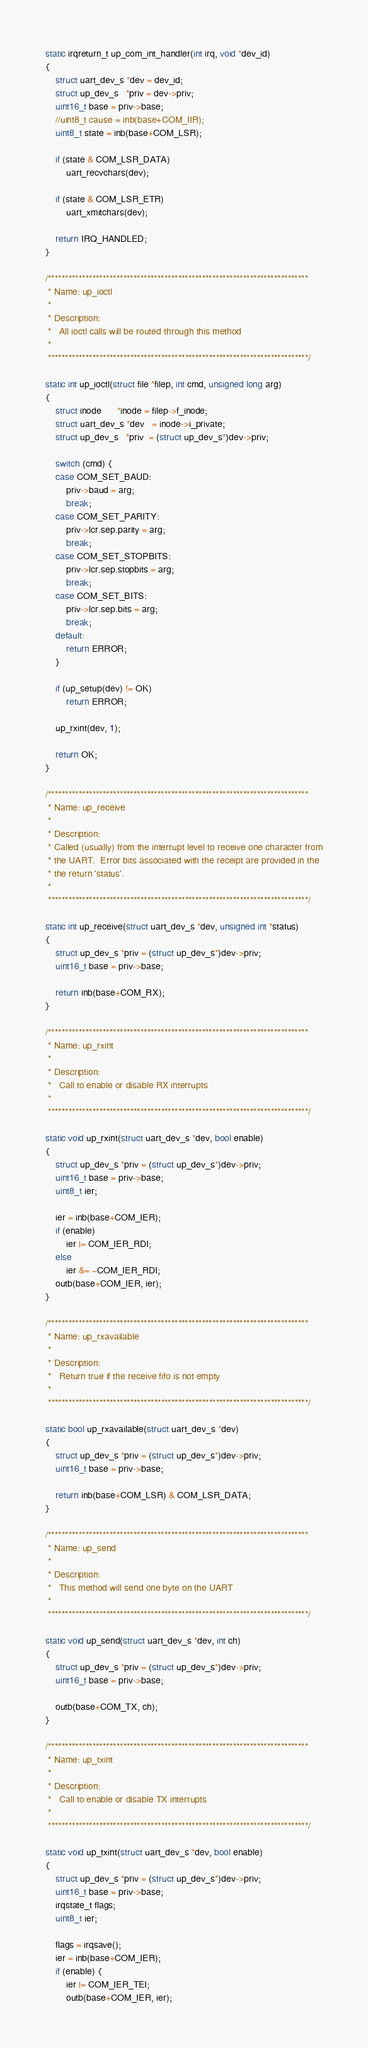<code> <loc_0><loc_0><loc_500><loc_500><_C_>
static irqreturn_t up_com_int_handler(int irq, void *dev_id)
{
    struct uart_dev_s *dev = dev_id;
    struct up_dev_s   *priv = dev->priv;
    uint16_t base = priv->base;
    //uint8_t cause = inb(base+COM_IIR);
    uint8_t state = inb(base+COM_LSR);

    if (state & COM_LSR_DATA)
        uart_recvchars(dev);

    if (state & COM_LSR_ETR)
        uart_xmitchars(dev);

    return IRQ_HANDLED;
}

/****************************************************************************
 * Name: up_ioctl
 *
 * Description:
 *   All ioctl calls will be routed through this method
 *
 ****************************************************************************/

static int up_ioctl(struct file *filep, int cmd, unsigned long arg)
{
    struct inode      *inode = filep->f_inode;
    struct uart_dev_s *dev   = inode->i_private;
    struct up_dev_s   *priv  = (struct up_dev_s*)dev->priv;
    
    switch (cmd) {
    case COM_SET_BAUD:
        priv->baud = arg;
        break;
    case COM_SET_PARITY:
        priv->lcr.sep.parity = arg;
        break;
    case COM_SET_STOPBITS:
        priv->lcr.sep.stopbits = arg;
        break;
    case COM_SET_BITS:
        priv->lcr.sep.bits = arg;
        break;
    default:
        return ERROR;
    }

    if (up_setup(dev) != OK)
        return ERROR;

    up_rxint(dev, 1);

    return OK;
}

/****************************************************************************
 * Name: up_receive
 *
 * Description:
 * Called (usually) from the interrupt level to receive one character from
 * the UART.  Error bits associated with the receipt are provided in the
 * the return 'status'.
 *
 ****************************************************************************/

static int up_receive(struct uart_dev_s *dev, unsigned int *status)
{
    struct up_dev_s *priv = (struct up_dev_s*)dev->priv;
    uint16_t base = priv->base;

    return inb(base+COM_RX);
}

/****************************************************************************
 * Name: up_rxint
 *
 * Description:
 *   Call to enable or disable RX interrupts
 *
 ****************************************************************************/

static void up_rxint(struct uart_dev_s *dev, bool enable)
{
    struct up_dev_s *priv = (struct up_dev_s*)dev->priv;
    uint16_t base = priv->base;
    uint8_t ier;

    ier = inb(base+COM_IER);
    if (enable)
        ier |= COM_IER_RDI;
    else
        ier &= ~COM_IER_RDI;
    outb(base+COM_IER, ier);
}

/****************************************************************************
 * Name: up_rxavailable
 *
 * Description:
 *   Return true if the receive fifo is not empty
 *
 ****************************************************************************/

static bool up_rxavailable(struct uart_dev_s *dev)
{
    struct up_dev_s *priv = (struct up_dev_s*)dev->priv;
    uint16_t base = priv->base;

    return inb(base+COM_LSR) & COM_LSR_DATA;
}

/****************************************************************************
 * Name: up_send
 *
 * Description:
 *   This method will send one byte on the UART
 *
 ****************************************************************************/

static void up_send(struct uart_dev_s *dev, int ch)
{
    struct up_dev_s *priv = (struct up_dev_s*)dev->priv;
    uint16_t base = priv->base;

    outb(base+COM_TX, ch);
}

/****************************************************************************
 * Name: up_txint
 *
 * Description:
 *   Call to enable or disable TX interrupts
 *
 ****************************************************************************/

static void up_txint(struct uart_dev_s *dev, bool enable)
{
    struct up_dev_s *priv = (struct up_dev_s*)dev->priv;
    uint16_t base = priv->base;
    irqstate_t flags;
    uint8_t ier;

    flags = irqsave();
    ier = inb(base+COM_IER);
    if (enable) {
        ier |= COM_IER_TEI;
        outb(base+COM_IER, ier);
</code> 